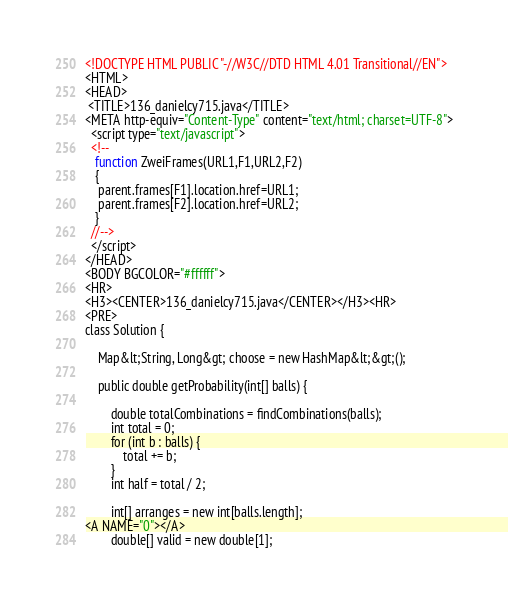<code> <loc_0><loc_0><loc_500><loc_500><_HTML_><!DOCTYPE HTML PUBLIC "-//W3C//DTD HTML 4.01 Transitional//EN">
<HTML>
<HEAD>
 <TITLE>136_danielcy715.java</TITLE>
<META http-equiv="Content-Type" content="text/html; charset=UTF-8">
  <script type="text/javascript">
  <!--
   function ZweiFrames(URL1,F1,URL2,F2)
   {
    parent.frames[F1].location.href=URL1;
    parent.frames[F2].location.href=URL2;
   }
  //-->
  </script>
</HEAD>
<BODY BGCOLOR="#ffffff">
<HR>
<H3><CENTER>136_danielcy715.java</CENTER></H3><HR>
<PRE>
class Solution {
    
    Map&lt;String, Long&gt; choose = new HashMap&lt;&gt;();
    
    public double getProbability(int[] balls) {
        
        double totalCombinations = findCombinations(balls);
        int total = 0;
        for (int b : balls) {
            total += b;
        }
        int half = total / 2;
        
        int[] arranges = new int[balls.length];
<A NAME="0"></A>        
        double[] valid = new double[1];</code> 